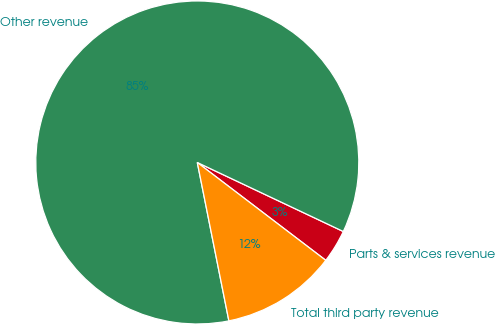Convert chart. <chart><loc_0><loc_0><loc_500><loc_500><pie_chart><fcel>Parts & services revenue<fcel>Other revenue<fcel>Total third party revenue<nl><fcel>3.33%<fcel>85.16%<fcel>11.51%<nl></chart> 